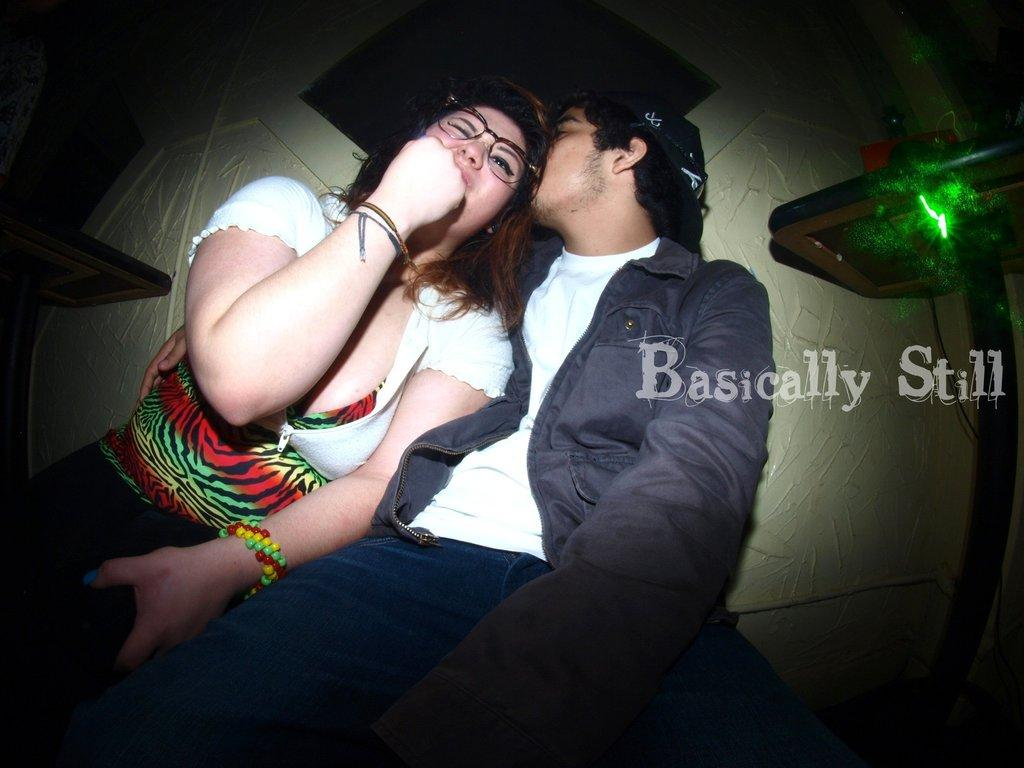What is the gender of the person in the image? There is a man and a woman in the image. What can be seen on the faces of both individuals? Both the man and the woman are wearing spectacles. What is visible in the background of the image? There is a wall in the background of the image. What type of tail can be seen on the man in the image? There is no tail present on the man in the image. 